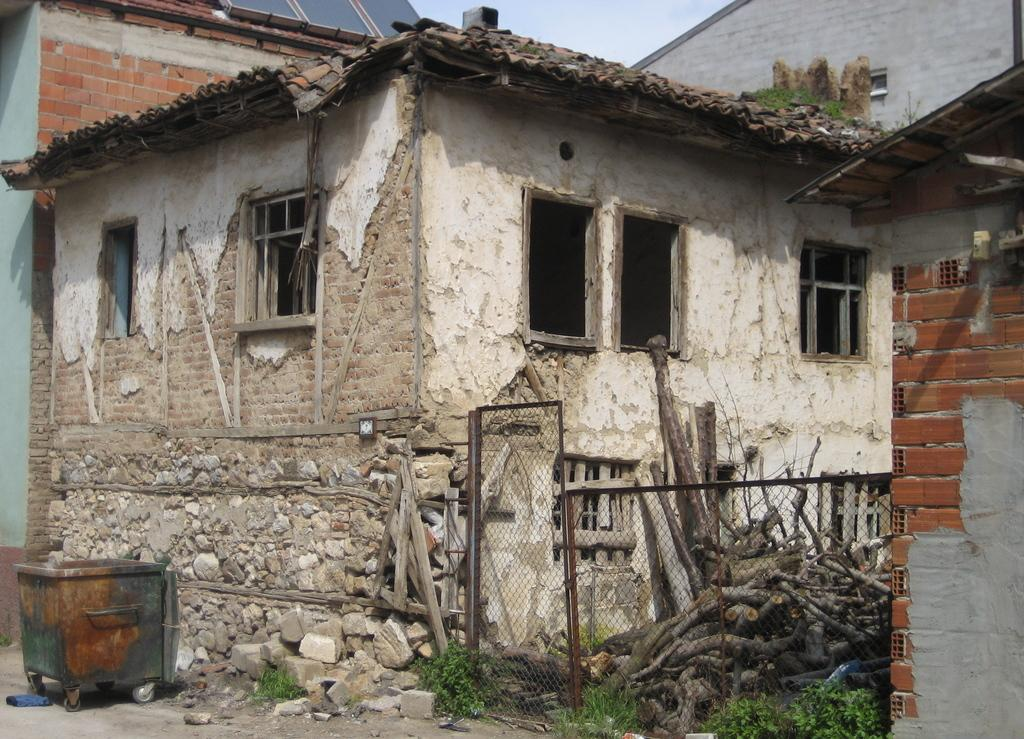What type of structures can be seen in the image? There are sheds in the image. What is located in the center of the image? There are logs in the center of the image. What type of barrier is present in the image? There is a fence in the image. What can be seen on the left side of the image? There is a trolley on the left side of the image. What is visible at the top of the image? The sky is visible at the top of the image. How many chairs are visible in the image? There are no chairs present in the image. What type of thumb is shown interacting with the logs in the image? There is no thumb present in the image; only logs, sheds, a fence, a trolley, and the sky are visible. 